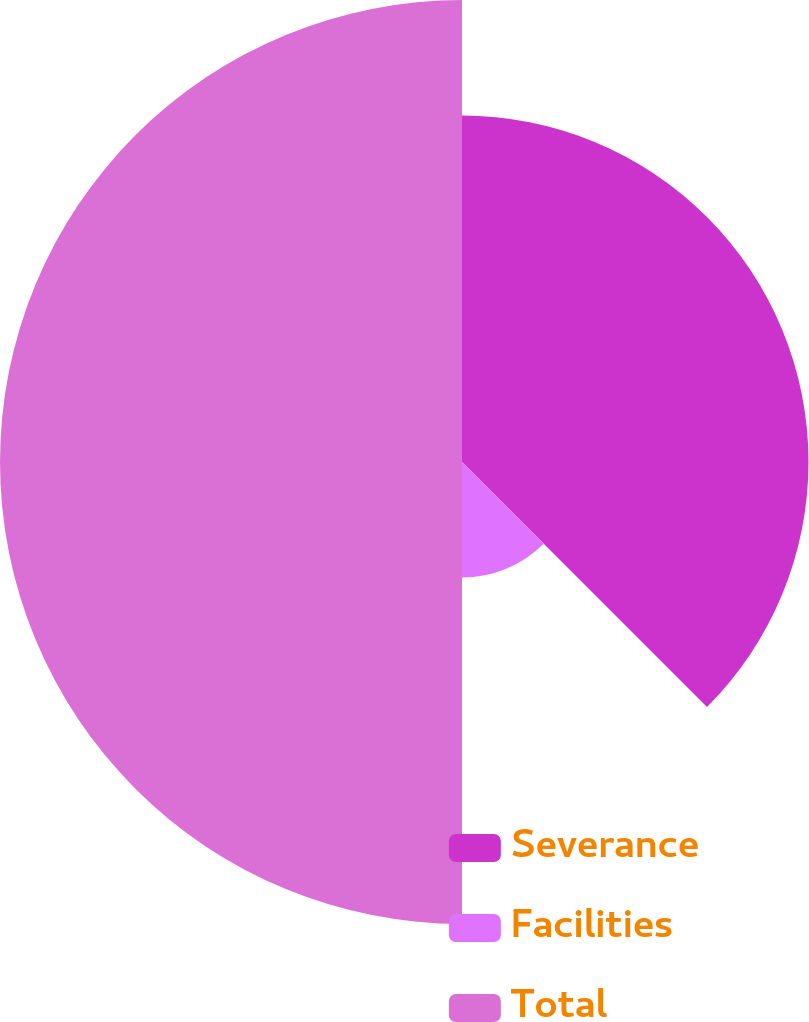Convert chart to OTSL. <chart><loc_0><loc_0><loc_500><loc_500><pie_chart><fcel>Severance<fcel>Facilities<fcel>Total<nl><fcel>37.5%<fcel>12.5%<fcel>50.0%<nl></chart> 